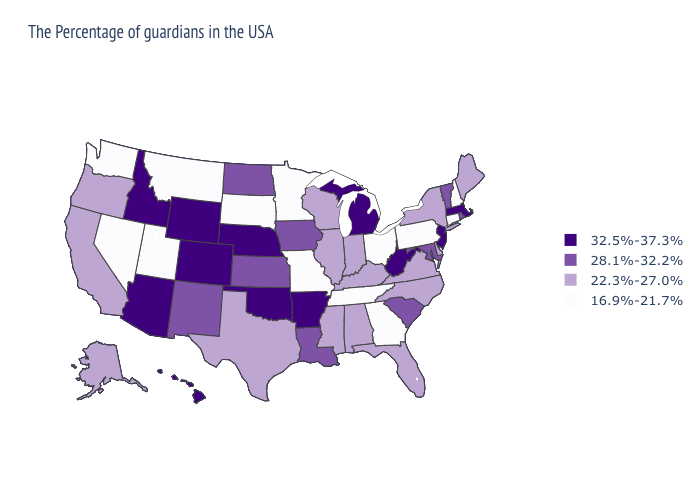Name the states that have a value in the range 32.5%-37.3%?
Short answer required. Massachusetts, New Jersey, West Virginia, Michigan, Arkansas, Nebraska, Oklahoma, Wyoming, Colorado, Arizona, Idaho, Hawaii. Is the legend a continuous bar?
Short answer required. No. Name the states that have a value in the range 28.1%-32.2%?
Quick response, please. Rhode Island, Vermont, Maryland, South Carolina, Louisiana, Iowa, Kansas, North Dakota, New Mexico. Does Iowa have the lowest value in the MidWest?
Quick response, please. No. Which states hav the highest value in the South?
Keep it brief. West Virginia, Arkansas, Oklahoma. What is the highest value in states that border Vermont?
Be succinct. 32.5%-37.3%. Among the states that border Georgia , does South Carolina have the highest value?
Answer briefly. Yes. Which states hav the highest value in the Northeast?
Write a very short answer. Massachusetts, New Jersey. Name the states that have a value in the range 28.1%-32.2%?
Answer briefly. Rhode Island, Vermont, Maryland, South Carolina, Louisiana, Iowa, Kansas, North Dakota, New Mexico. Does the first symbol in the legend represent the smallest category?
Give a very brief answer. No. What is the lowest value in the MidWest?
Concise answer only. 16.9%-21.7%. Is the legend a continuous bar?
Quick response, please. No. Among the states that border Illinois , which have the lowest value?
Quick response, please. Missouri. Name the states that have a value in the range 32.5%-37.3%?
Answer briefly. Massachusetts, New Jersey, West Virginia, Michigan, Arkansas, Nebraska, Oklahoma, Wyoming, Colorado, Arizona, Idaho, Hawaii. Does Virginia have a higher value than West Virginia?
Concise answer only. No. 